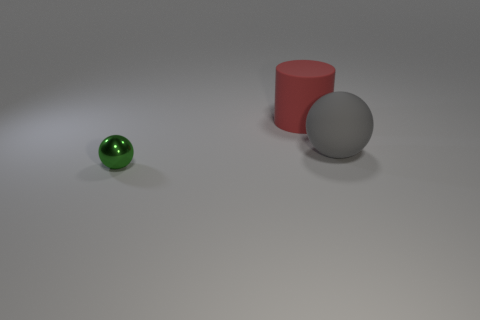Could you describe the lighting in the scene? The lighting in the scene is soft and diffused, coming from above. There are gentle shadows beneath the objects which indicate a single light source without harsh direct light, giving the scene a calm and even tone. 